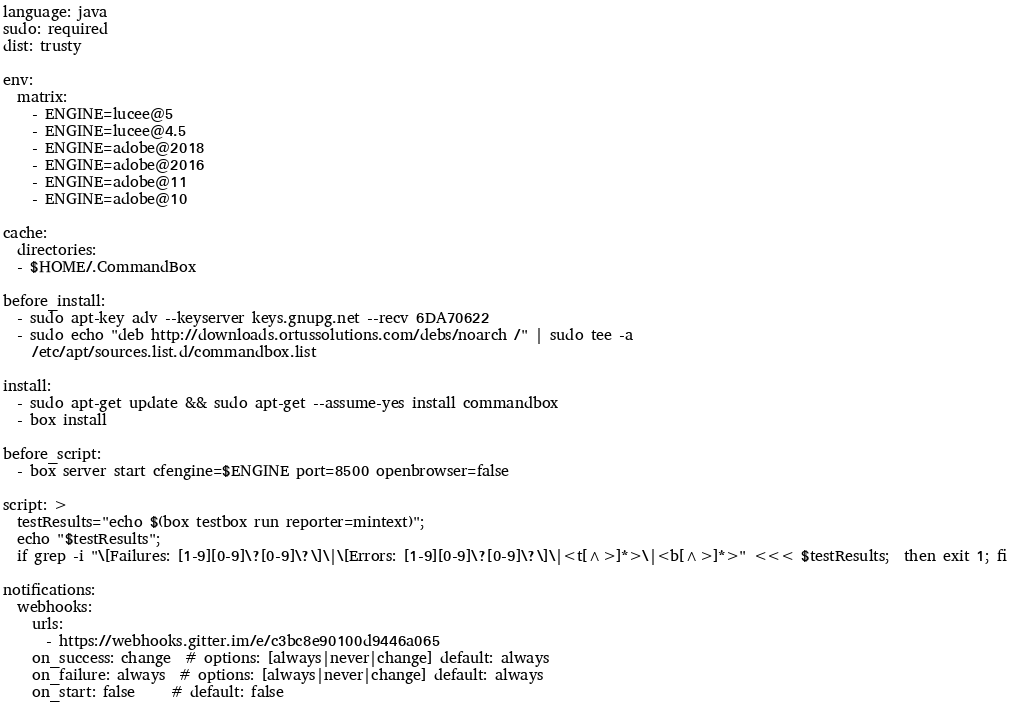<code> <loc_0><loc_0><loc_500><loc_500><_YAML_>language: java
sudo: required
dist: trusty

env:
  matrix:
    - ENGINE=lucee@5
    - ENGINE=lucee@4.5
    - ENGINE=adobe@2018
    - ENGINE=adobe@2016
    - ENGINE=adobe@11
    - ENGINE=adobe@10

cache:
  directories:
  - $HOME/.CommandBox

before_install:
  - sudo apt-key adv --keyserver keys.gnupg.net --recv 6DA70622
  - sudo echo "deb http://downloads.ortussolutions.com/debs/noarch /" | sudo tee -a
    /etc/apt/sources.list.d/commandbox.list

install:
  - sudo apt-get update && sudo apt-get --assume-yes install commandbox
  - box install

before_script:
  - box server start cfengine=$ENGINE port=8500 openbrowser=false

script: >
  testResults="echo $(box testbox run reporter=mintext)";
  echo "$testResults";
  if grep -i "\[Failures: [1-9][0-9]\?[0-9]\?\]\|\[Errors: [1-9][0-9]\?[0-9]\?\]\|<t[^>]*>\|<b[^>]*>" <<< $testResults;  then exit 1; fi

notifications:
  webhooks:
    urls:
      - https://webhooks.gitter.im/e/c3bc8e90100d9446a065
    on_success: change  # options: [always|never|change] default: always
    on_failure: always  # options: [always|never|change] default: always
    on_start: false     # default: false
</code> 